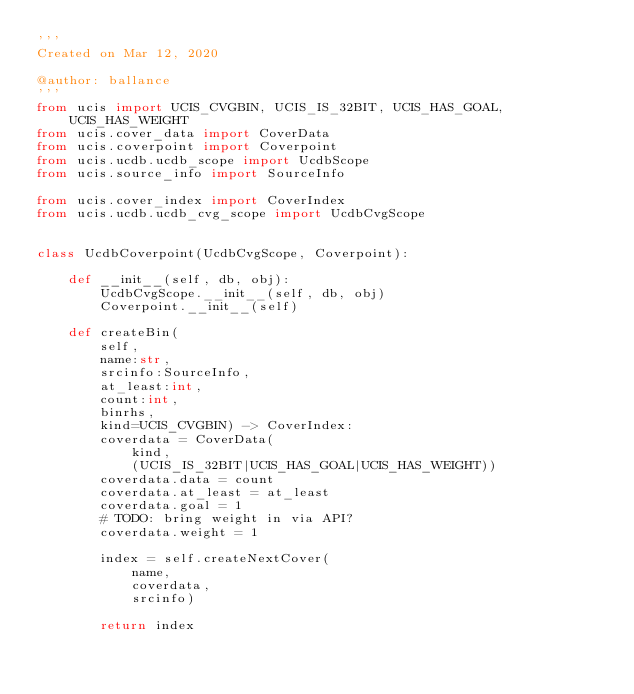Convert code to text. <code><loc_0><loc_0><loc_500><loc_500><_Python_>'''
Created on Mar 12, 2020

@author: ballance
'''
from ucis import UCIS_CVGBIN, UCIS_IS_32BIT, UCIS_HAS_GOAL, UCIS_HAS_WEIGHT
from ucis.cover_data import CoverData
from ucis.coverpoint import Coverpoint
from ucis.ucdb.ucdb_scope import UcdbScope
from ucis.source_info import SourceInfo

from ucis.cover_index import CoverIndex
from ucis.ucdb.ucdb_cvg_scope import UcdbCvgScope


class UcdbCoverpoint(UcdbCvgScope, Coverpoint):
    
    def __init__(self, db, obj):
        UcdbCvgScope.__init__(self, db, obj)
        Coverpoint.__init__(self)
        
    def createBin(
        self, 
        name:str, 
        srcinfo:SourceInfo, 
        at_least:int, 
        count:int,
        binrhs,
        kind=UCIS_CVGBIN) -> CoverIndex:
        coverdata = CoverData(
            kind,
            (UCIS_IS_32BIT|UCIS_HAS_GOAL|UCIS_HAS_WEIGHT))
        coverdata.data = count
        coverdata.at_least = at_least
        coverdata.goal = 1
        # TODO: bring weight in via API?
        coverdata.weight = 1
        
        index = self.createNextCover(
            name, 
            coverdata,
            srcinfo)
        
        return index
        </code> 